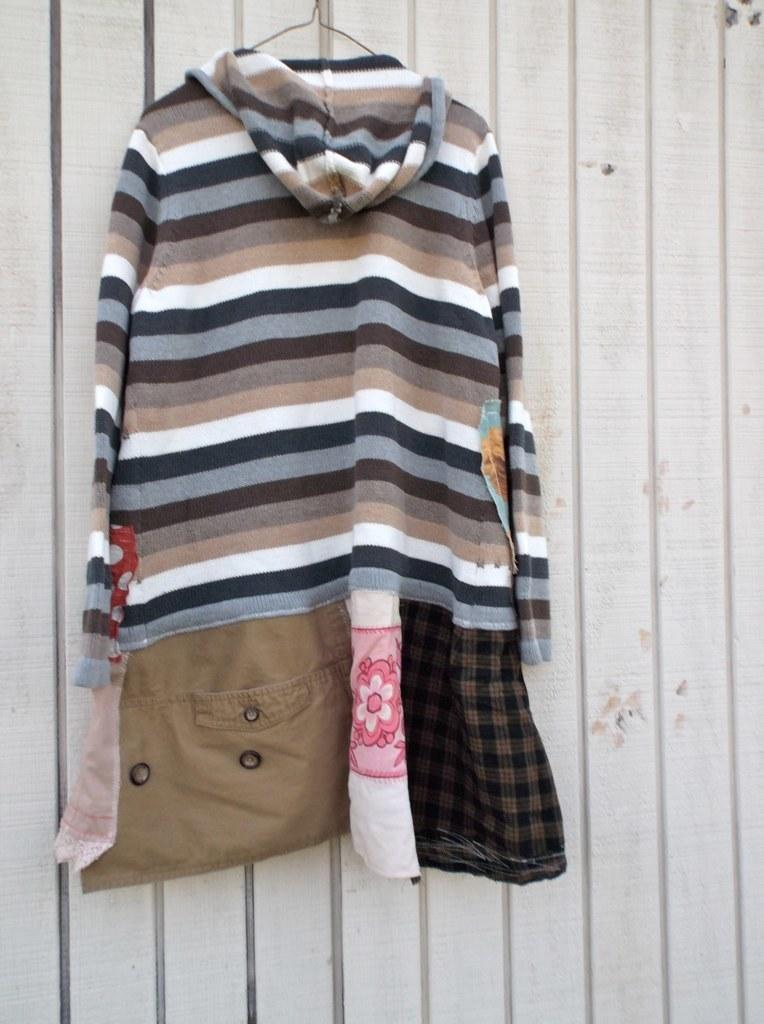What is hanging on the hanger in the image? There are clothes on a hanger in the image. What type of material can be seen in the background of the image? There is a wooden wall in the background of the image. How many legs can be seen on the cheese in the image? There is no cheese present in the image, and therefore no legs can be seen on it. 